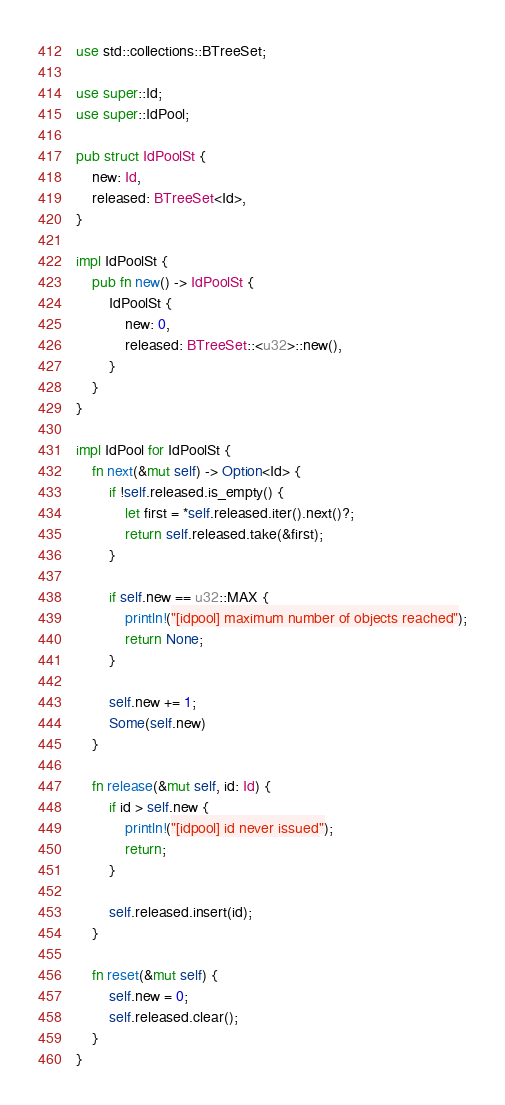Convert code to text. <code><loc_0><loc_0><loc_500><loc_500><_Rust_>use std::collections::BTreeSet;

use super::Id;
use super::IdPool;

pub struct IdPoolSt {
    new: Id,
    released: BTreeSet<Id>,
}

impl IdPoolSt {
    pub fn new() -> IdPoolSt {
        IdPoolSt {
            new: 0,
            released: BTreeSet::<u32>::new(),
        }
    }
}

impl IdPool for IdPoolSt {
    fn next(&mut self) -> Option<Id> {
        if !self.released.is_empty() {
            let first = *self.released.iter().next()?;
            return self.released.take(&first);
        }

        if self.new == u32::MAX {
            println!("[idpool] maximum number of objects reached");
            return None;
        }

        self.new += 1;
        Some(self.new)
    }

    fn release(&mut self, id: Id) {
        if id > self.new {
            println!("[idpool] id never issued");
            return;
        }

        self.released.insert(id);
    }

    fn reset(&mut self) {
        self.new = 0;
        self.released.clear();
    }
}
</code> 